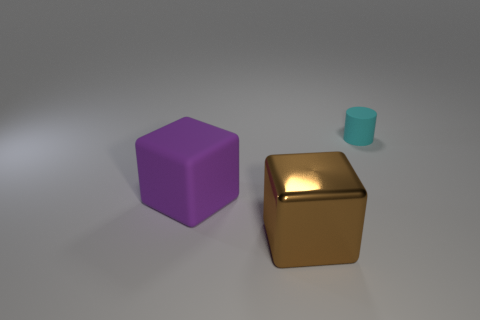Add 3 big blocks. How many objects exist? 6 Subtract all blocks. How many objects are left? 1 Subtract all green cylinders. Subtract all brown balls. How many cylinders are left? 1 Subtract all red cylinders. How many blue cubes are left? 0 Subtract all matte blocks. Subtract all tiny cylinders. How many objects are left? 1 Add 2 brown objects. How many brown objects are left? 3 Add 3 large brown cubes. How many large brown cubes exist? 4 Subtract 0 gray cubes. How many objects are left? 3 